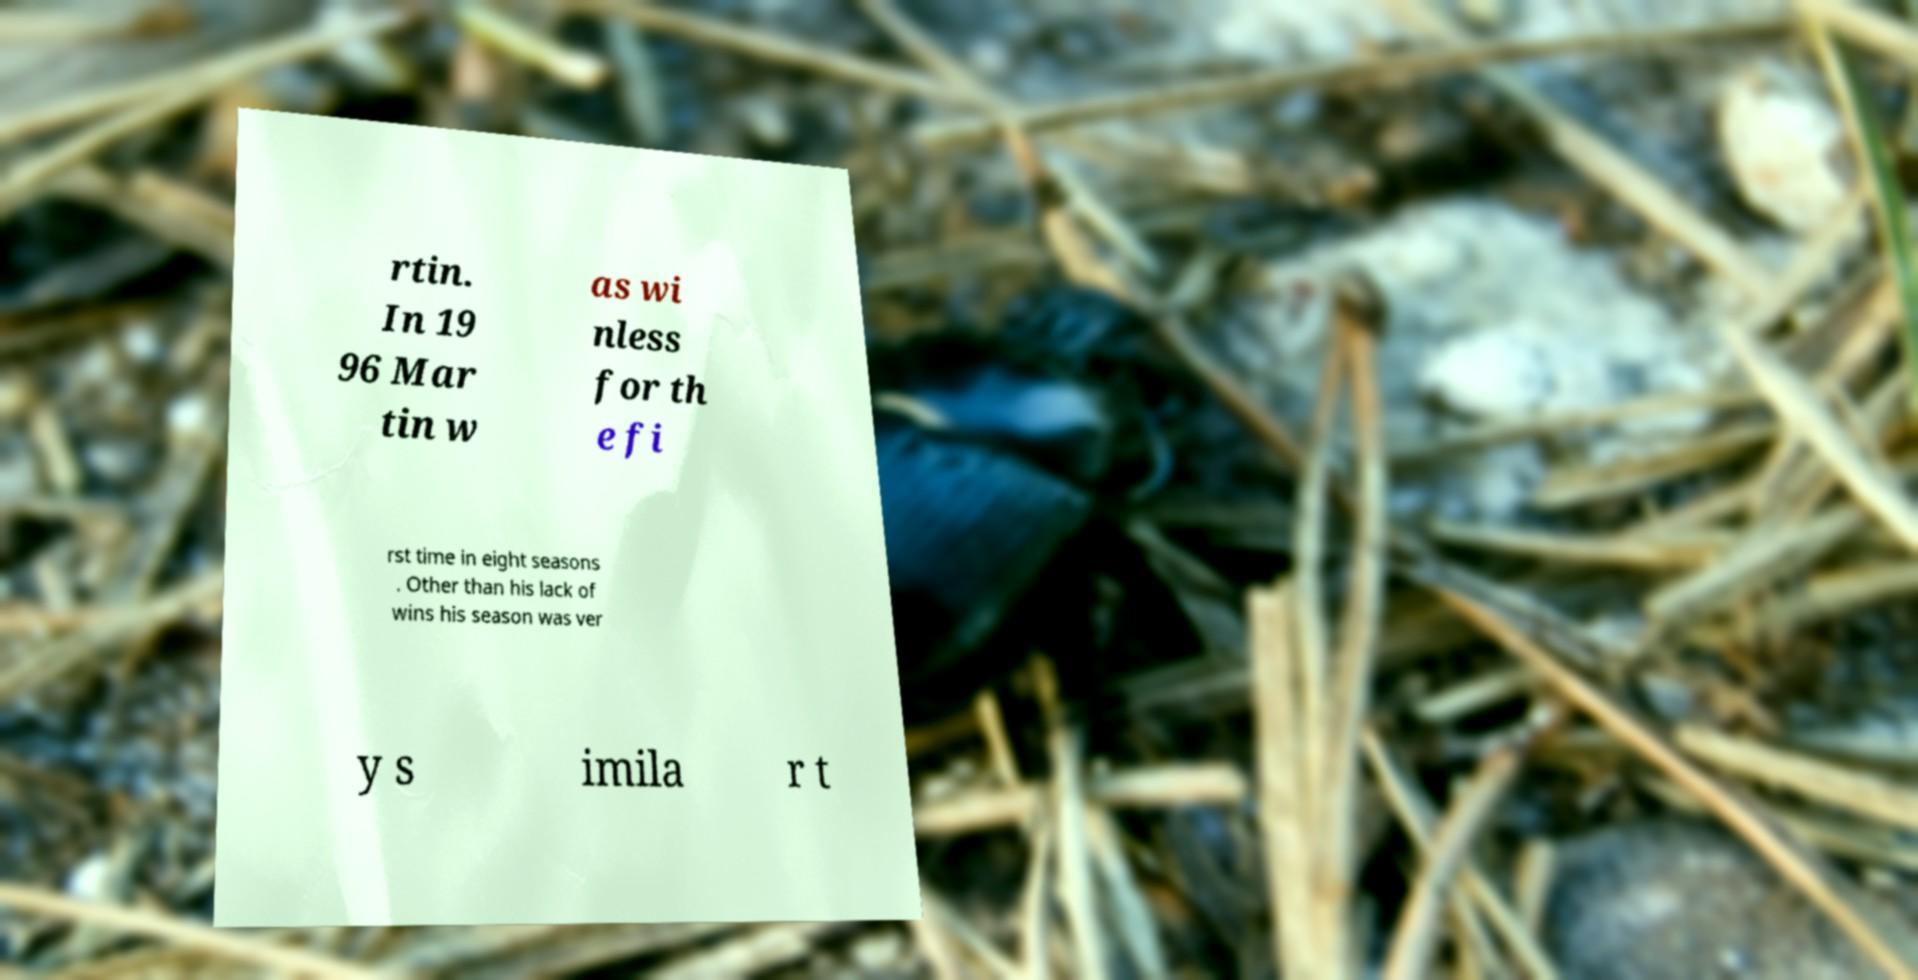Please identify and transcribe the text found in this image. rtin. In 19 96 Mar tin w as wi nless for th e fi rst time in eight seasons . Other than his lack of wins his season was ver y s imila r t 